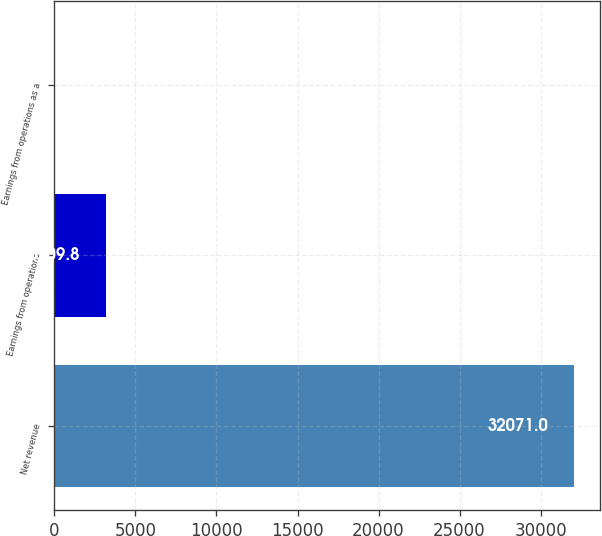Convert chart. <chart><loc_0><loc_0><loc_500><loc_500><bar_chart><fcel>Net revenue<fcel>Earnings from operations<fcel>Earnings from operations as a<nl><fcel>32071<fcel>3209.8<fcel>3<nl></chart> 